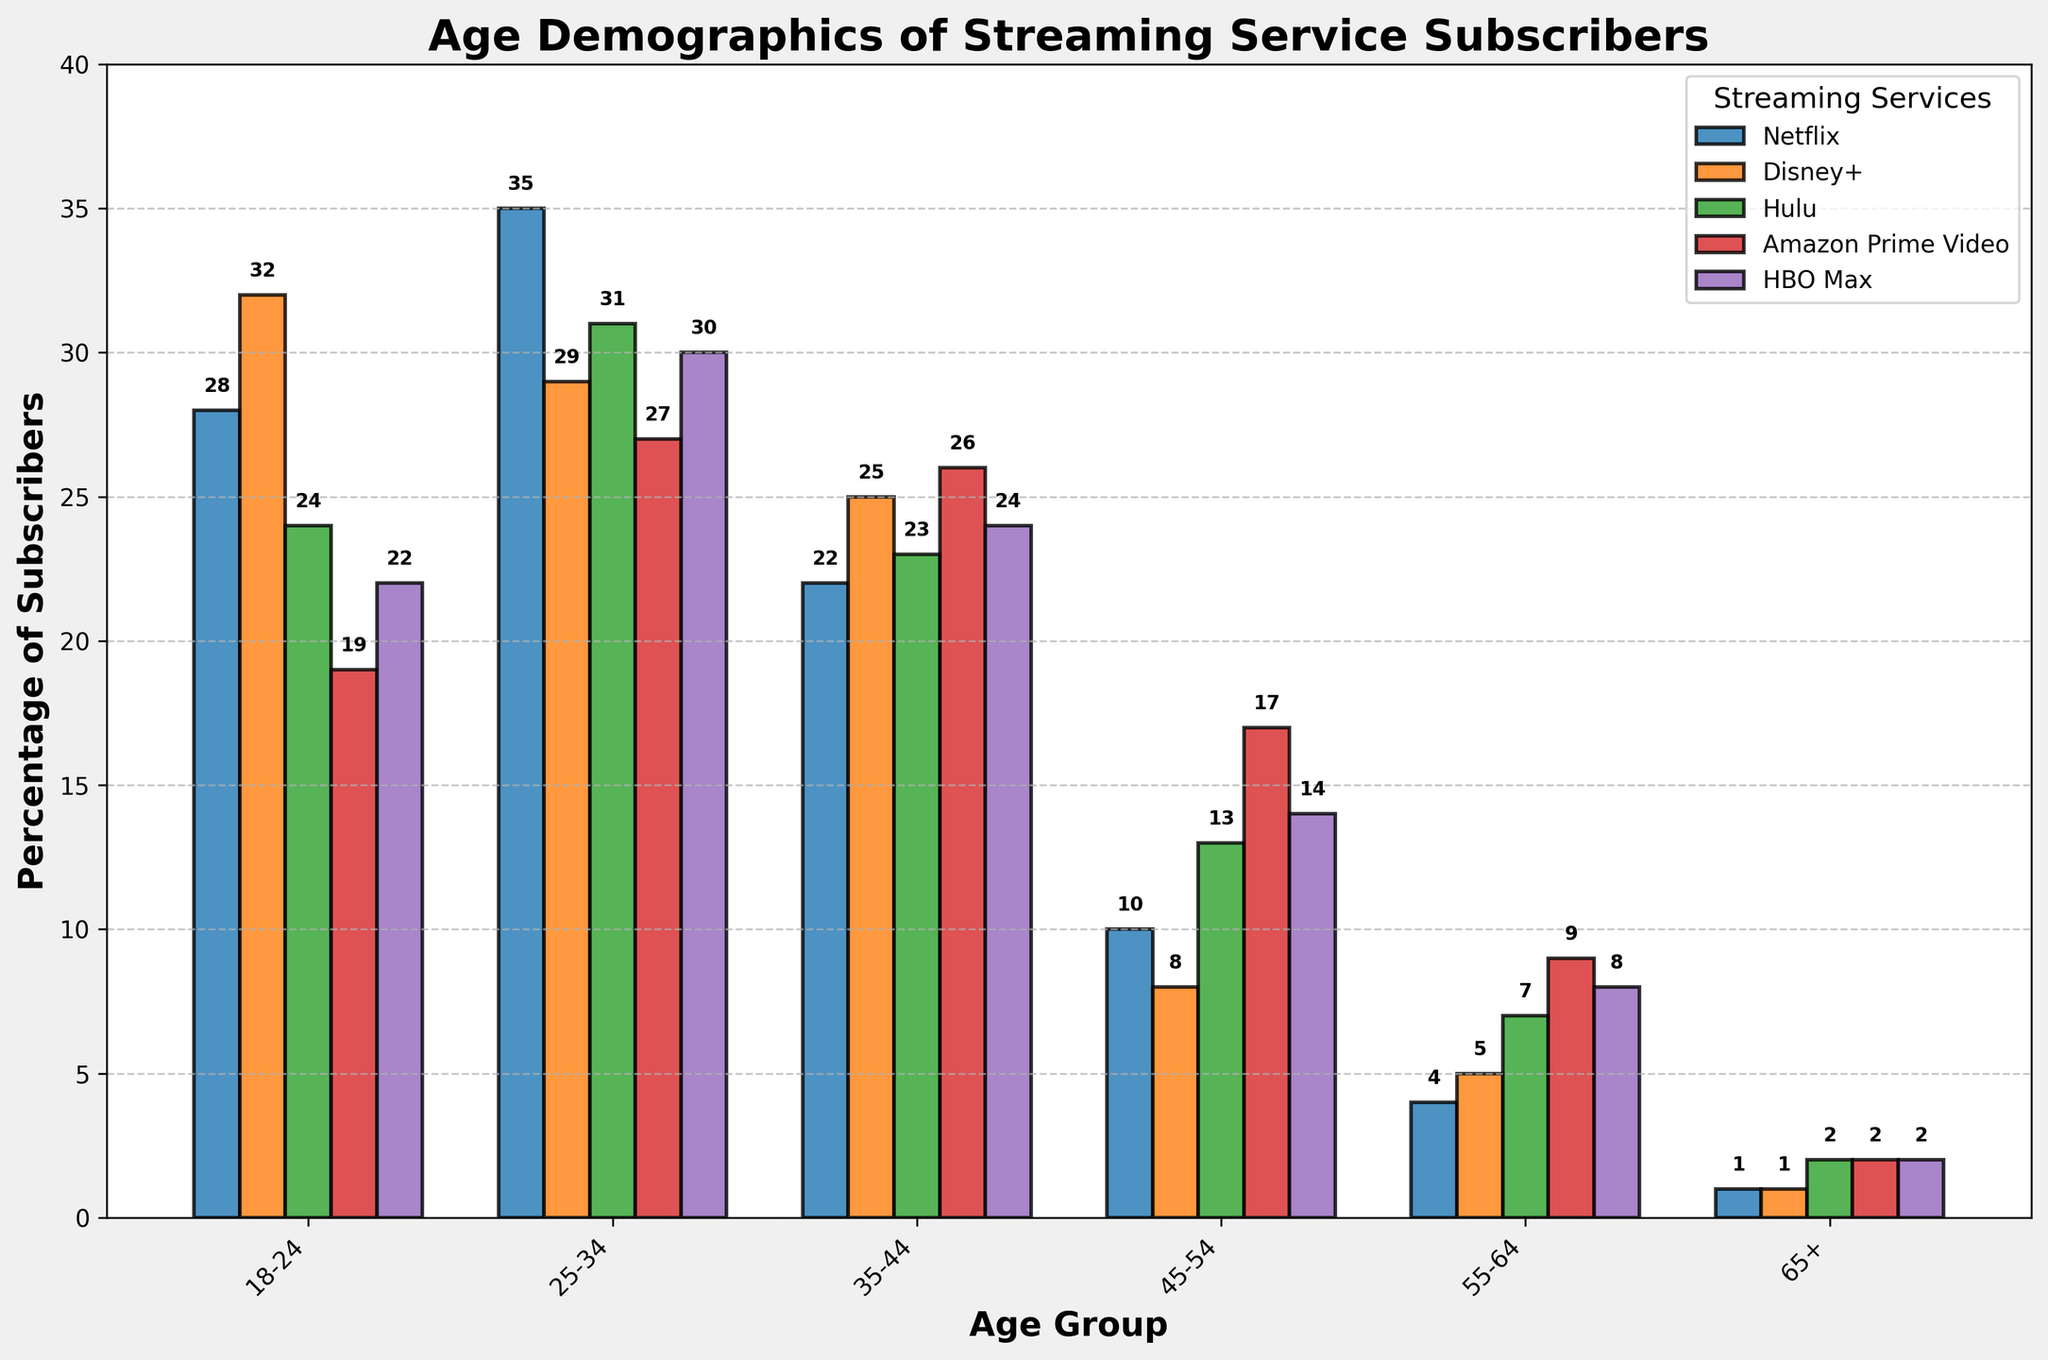Which age group has the highest percentage of Netflix subscribers? Look at the highest bar in the Netflix category. The age group with the highest bar should be the one with the highest percentage.
Answer: 25-34 Which streaming service has the lowest percentage of subscribers in the 65+ age group? Look at the bars for the 65+ age group across all streaming services, and identify the lowest one.
Answer: Netflix, Disney+ What is the sum of subscribers' percentages for Amazon Prime Video in the 18-24 and 25-34 age groups? Sum the heights of the bars for Amazon Prime Video in both the 18-24 and 25-34 age groups. The values are 19 and 27. So, 19 + 27 = 46.
Answer: 46 Compare the percentages of subscribers between Hulu and HBO Max in the 35-44 age group. Which service is more popular and by how much? Look at the bars for the 35-44 age group for Hulu and HBO Max. The values are 23 and 24. HBO Max is higher by 1. 24 - 23 = 1.
Answer: HBO Max, by 1 Calculate the average percentage of subscribers across all age groups for Disney+. The values for Disney+ across all age groups are 32, 29, 25, 8, 5, and 1. Sum these values: 32 + 29 + 25 + 8 + 5 + 1 = 100. There are 6 age groups, so divide by 6. The average is 100/6 ≈ 16.67.
Answer: 16.67 What is the total percentage of subscribers for HBO Max across all age groups? Sum the percentages for HBO Max across all age groups: 22, 30, 24, 14, 8, and 2. So, 22 + 30 + 24 + 14 + 8 + 2 = 100.
Answer: 100 How much more popular is Netflix than Hulu in the 25-34 age group? Compare the bars for the 25-34 age group for Netflix and Hulu. The values are 35 and 31, so 35 - 31 = 4.
Answer: 4 Which streaming service shows a significant increase in subscriber percentage moving from the 55-64 to the 45-54 age group? Compare the bar heights for the 55-64 and 45-54 age groups across all services. Identify any significant increases. Hulu shows an increase from 7 to 13 (6), and Amazon Prime Video shows an increase from 9 to 17 (8). Amazon Prime Video has a significant increase.
Answer: Amazon Prime Video 